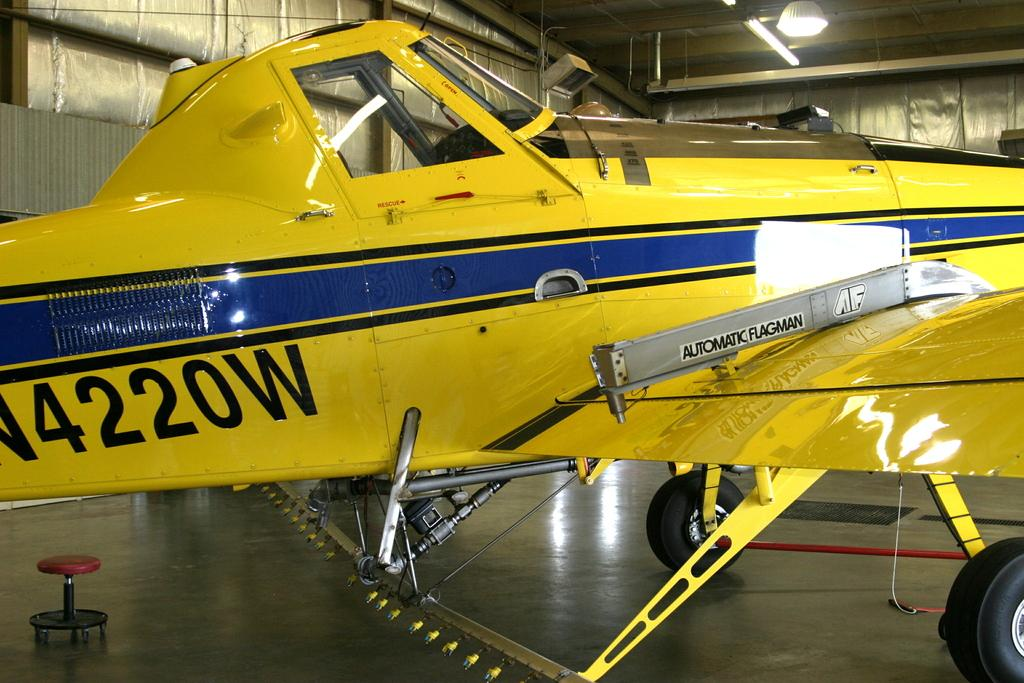<image>
Describe the image concisely. A yellow, small plane with the numbers 4220 on its side 